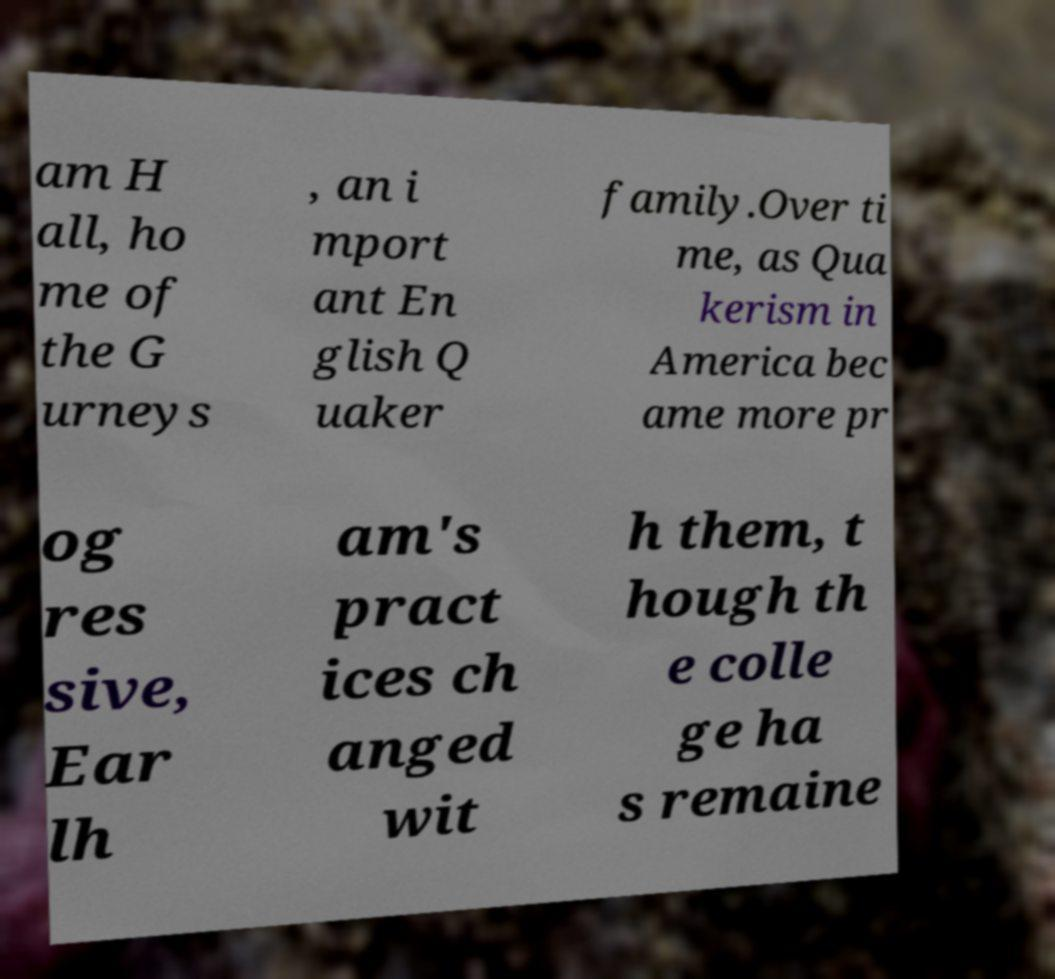Please read and relay the text visible in this image. What does it say? am H all, ho me of the G urneys , an i mport ant En glish Q uaker family.Over ti me, as Qua kerism in America bec ame more pr og res sive, Ear lh am's pract ices ch anged wit h them, t hough th e colle ge ha s remaine 